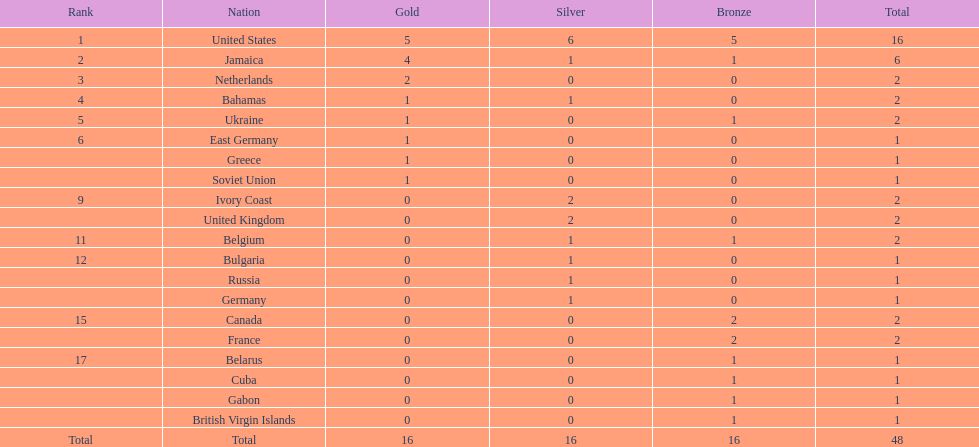Following the united states, which nation secured the most gold medals? Jamaica. Give me the full table as a dictionary. {'header': ['Rank', 'Nation', 'Gold', 'Silver', 'Bronze', 'Total'], 'rows': [['1', 'United States', '5', '6', '5', '16'], ['2', 'Jamaica', '4', '1', '1', '6'], ['3', 'Netherlands', '2', '0', '0', '2'], ['4', 'Bahamas', '1', '1', '0', '2'], ['5', 'Ukraine', '1', '0', '1', '2'], ['6', 'East Germany', '1', '0', '0', '1'], ['', 'Greece', '1', '0', '0', '1'], ['', 'Soviet Union', '1', '0', '0', '1'], ['9', 'Ivory Coast', '0', '2', '0', '2'], ['', 'United Kingdom', '0', '2', '0', '2'], ['11', 'Belgium', '0', '1', '1', '2'], ['12', 'Bulgaria', '0', '1', '0', '1'], ['', 'Russia', '0', '1', '0', '1'], ['', 'Germany', '0', '1', '0', '1'], ['15', 'Canada', '0', '0', '2', '2'], ['', 'France', '0', '0', '2', '2'], ['17', 'Belarus', '0', '0', '1', '1'], ['', 'Cuba', '0', '0', '1', '1'], ['', 'Gabon', '0', '0', '1', '1'], ['', 'British Virgin Islands', '0', '0', '1', '1'], ['Total', 'Total', '16', '16', '16', '48']]} 